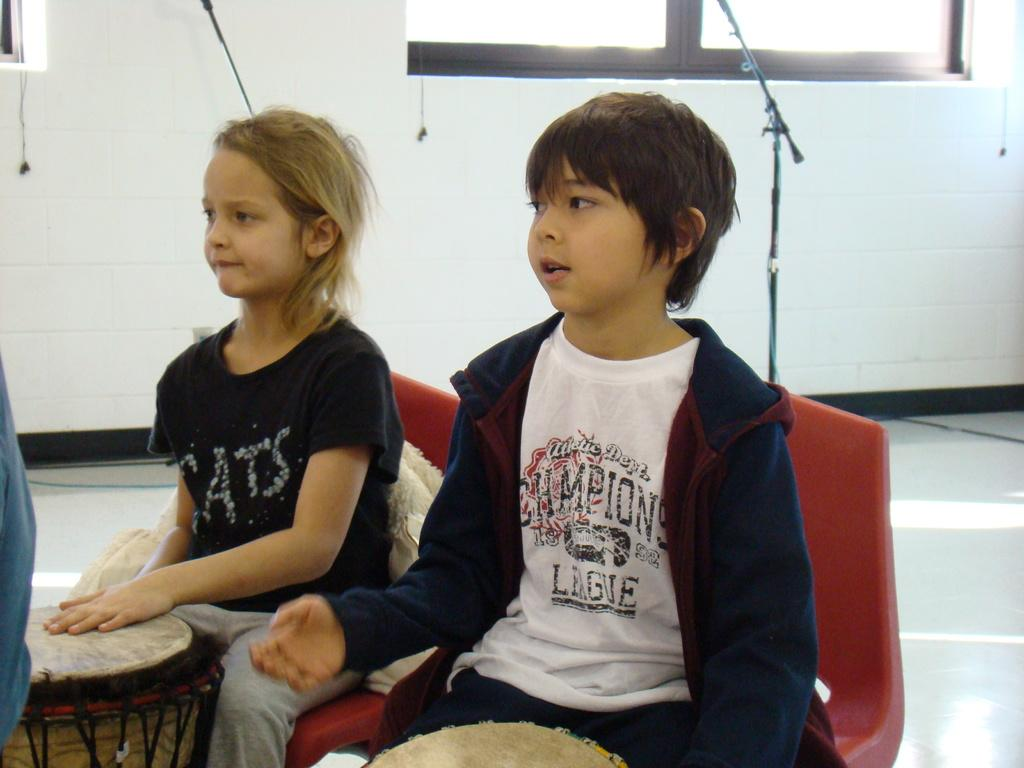How many chairs are visible in the image? There are two chairs in the image. What other objects can be seen in the image? There are mic stands, windows, and drums visible in the image. What are the children doing in the image? Two children are sitting on the chairs in the image. What color are the children's dresses? The children are wearing black color dresses. Where are the windows located in the image? The windows are on the top of the image. Can you tell me how many nerves are visible in the image? There are no nerves visible in the image; it features chairs, mic stands, windows, drums, and children. What type of table is present in the image? There is no table present in the image. 